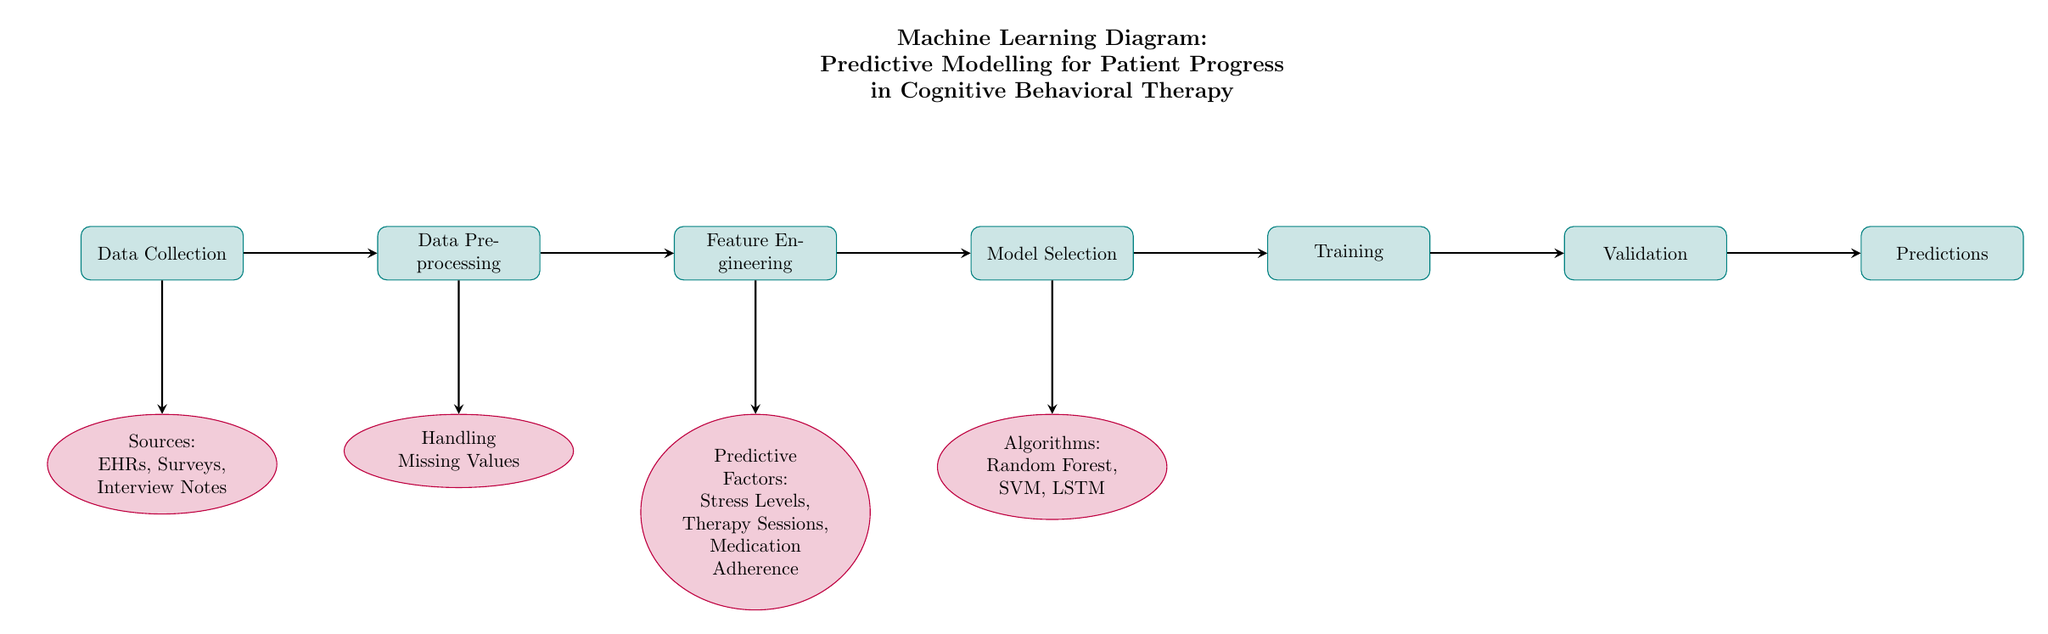What are the data sources used in the model? The diagram indicates that the data sources consist of Electronic Health Records (EHRs), Surveys, and Interview Notes, listed under the "Sources" node connected to "Data Collection."
Answer: EHRs, Surveys, Interview Notes What process comes after "Model Selection"? The diagram shows that the process following "Model Selection" is "Training," indicating the flow of activities in predictive modeling.
Answer: Training How many predictive factors are identified? Within the "Predictive Factors" node, three specific factors are mentioned: Stress Levels, Therapy Sessions, and Medication Adherence, which signifies the total number of factors.
Answer: Three Which algorithms are mentioned for the model? The "Algorithms" node lists three algorithms: Random Forest, SVM, and LSTM, connected to "Model Selection."
Answer: Random Forest, SVM, LSTM What is the last process in the flow? The final process noted in the diagram is "Predictions," indicating this is the concluding step after all preceding processes have been completed.
Answer: Predictions Which process precedes "Validation"? The diagram depicts that "Training" comes immediately before "Validation," showing the chronological order of operations.
Answer: Training What type of diagram is presented? The title in the diagram explicitly states that it is a "Machine Learning Diagram," indicating its focus on predictive modeling in a healthcare context.
Answer: Machine Learning Diagram How are missing values handled? The node labeled "Handling Missing Values" illustrates that this is a specific process that occurs during the "Data Preprocessing" phase of the modeling.
Answer: Handling Missing Values What type of node is "Feature Engineering"? The "Feature Engineering" node is categorized as a process node, as indicated by its rectangle shape and description in the diagram.
Answer: Process 